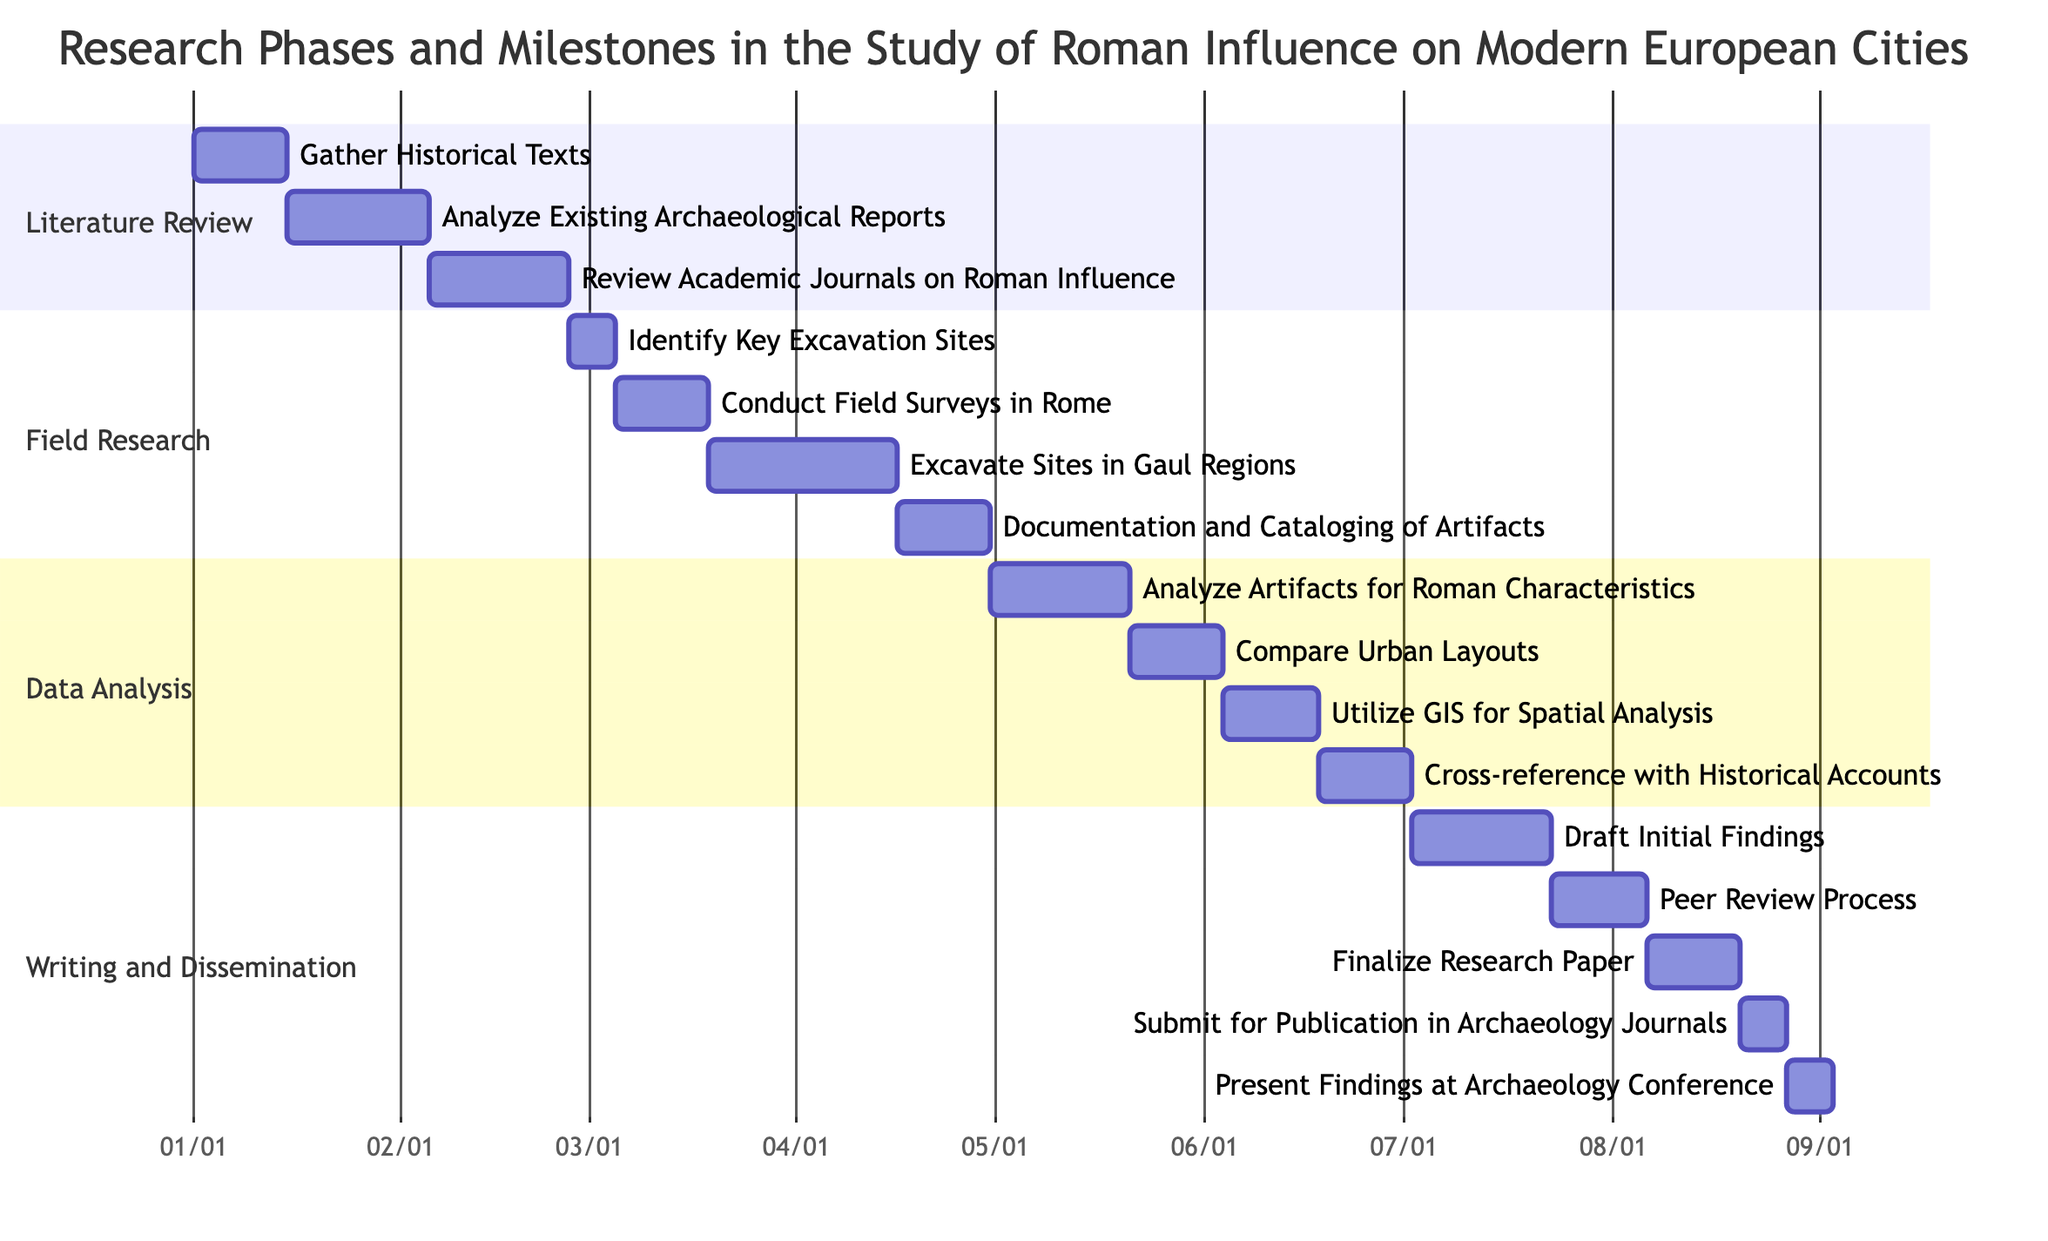What is the total duration of the "Field Research" phase? The "Field Research" phase consists of four milestones. The durations are: Identify Key Excavation Sites (1 week), Conduct Field Surveys in Rome (2 weeks), Excavate Sites in Gaul Regions (4 weeks), and Documentation and Cataloging of Artifacts (2 weeks). Adding these together gives 1 + 2 + 4 + 2 = 9 weeks.
Answer: 9 weeks Which milestone in the "Data Analysis" phase is the longest? In the "Data Analysis" phase, the milestones and their durations are: Analyze Artifacts for Roman Characteristics (3 weeks), Compare Urban Layouts (2 weeks), Utilize GIS for Spatial Analysis (2 weeks), and Cross-reference with Historical Accounts (2 weeks). The longest duration is from "Analyze Artifacts for Roman Characteristics", which lasts 3 weeks.
Answer: Analyze Artifacts for Roman Characteristics When does the "Peer Review Process" start? The "Peer Review Process" milestone is located within the "Writing and Dissemination" phase. According to the diagram, it starts after "Draft Initial Findings", which lasts for 3 weeks, bringing the start date to July 23, 2023.
Answer: July 23, 2023 How many total milestones are in the "Literature Review" phase? The "Literature Review" phase includes three milestones: Gather Historical Texts, Analyze Existing Archaeological Reports, and Review Academic Journals on Roman Influence. Counting these gives a total of 3 milestones.
Answer: 3 milestones What is the duration of the "Excavate Sites in Gaul Regions"? The milestone "Excavate Sites in Gaul Regions" under the "Field Research" phase has a specified duration of 4 weeks directly shown in the diagram.
Answer: 4 weeks In which phase is "Utilize GIS for Spatial Analysis" found? The milestone "Utilize GIS for Spatial Analysis" is listed under the phase "Data Analysis". This can be verified directly from the diagram, which shows it as part of the specified phase.
Answer: Data Analysis What milestone follows "Conduct Field Surveys in Rome"? The "Conduct Field Surveys in Rome" milestone has a duration of 2 weeks and is immediately followed by the "Excavate Sites in Gaul Regions" milestone, which starts after it ends.
Answer: Excavate Sites in Gaul Regions How many weeks are allocated for writing and dissemination in total? The "Writing and Dissemination" phase has the following milestones with their durations: Draft Initial Findings (3 weeks), Peer Review Process (2 weeks), Finalize Research Paper (2 weeks), Submit for Publication in Archaeology Journals (1 week), Present Findings at Archaeology Conference (1 week). Adding these gives 3 + 2 + 2 + 1 + 1 = 9 weeks total.
Answer: 9 weeks 